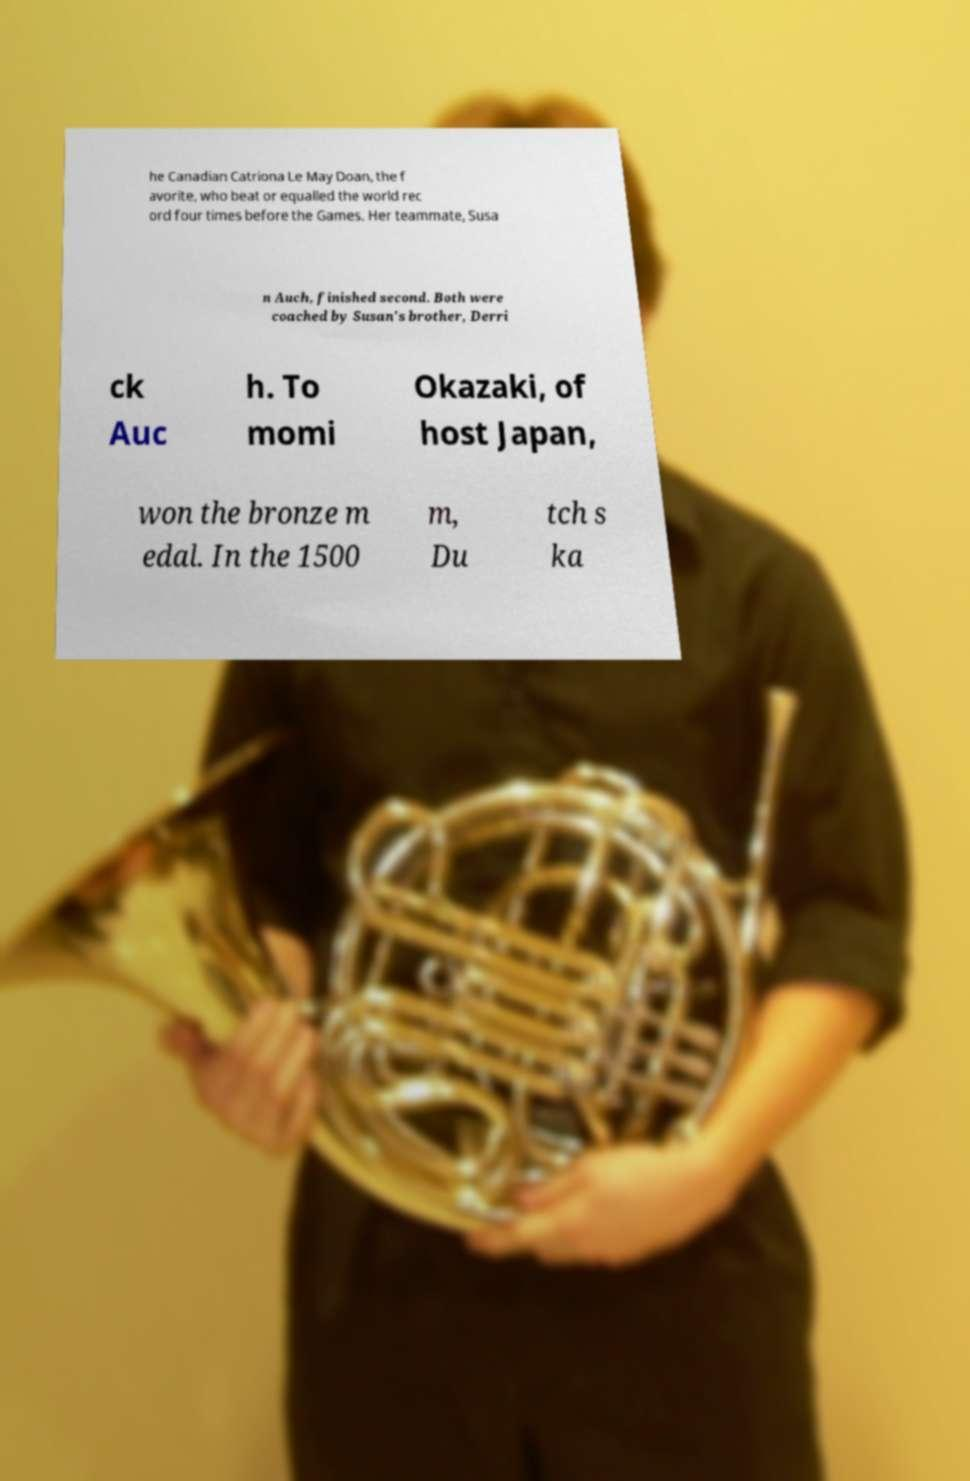Could you assist in decoding the text presented in this image and type it out clearly? he Canadian Catriona Le May Doan, the f avorite, who beat or equalled the world rec ord four times before the Games. Her teammate, Susa n Auch, finished second. Both were coached by Susan's brother, Derri ck Auc h. To momi Okazaki, of host Japan, won the bronze m edal. In the 1500 m, Du tch s ka 